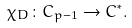<formula> <loc_0><loc_0><loc_500><loc_500>\chi _ { D } \colon C _ { p - 1 } \rightarrow { C } ^ { * } .</formula> 